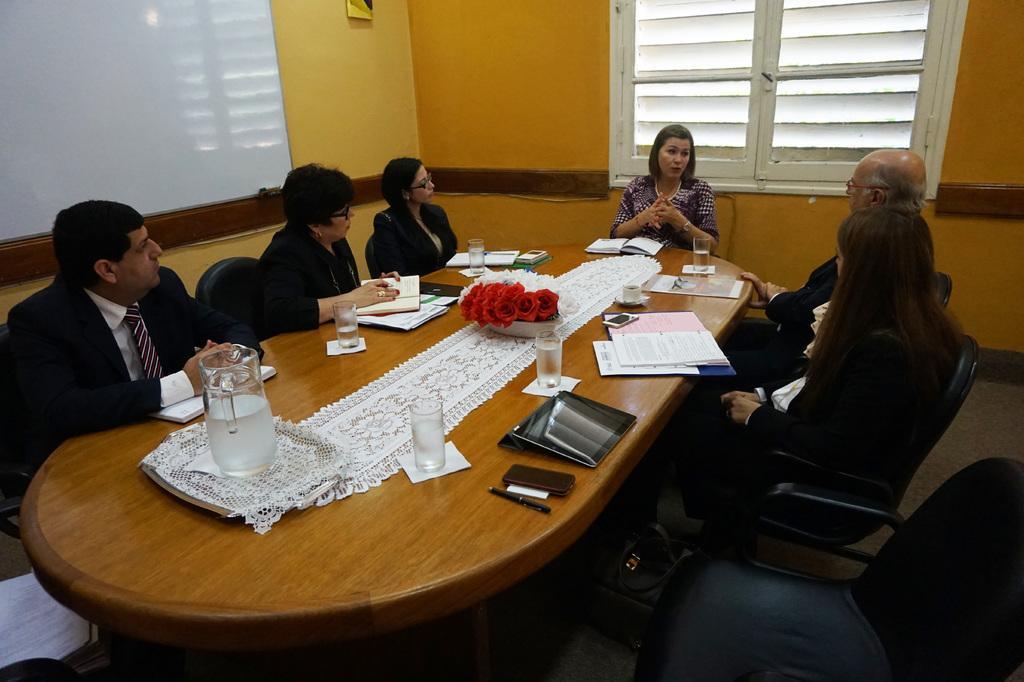Could you give a brief overview of what you see in this image? In this image we can see a six people who are gathered in a room. They are sitting on a chair and they are discussing about something important. This is a wooden table where a water jar , glasses and files are kept on it. Here we can see a screen and this is a window. 